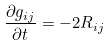<formula> <loc_0><loc_0><loc_500><loc_500>\frac { { \partial } { g _ { i j } } } { { \partial } t } = - 2 { R _ { i j } }</formula> 